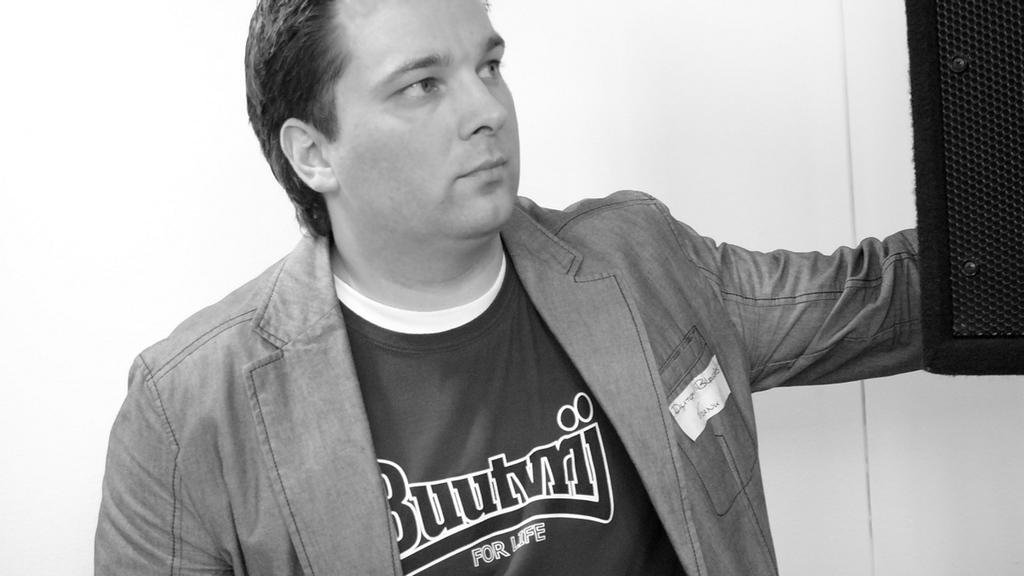<image>
Render a clear and concise summary of the photo. a man wearing a tshirt that says for life 